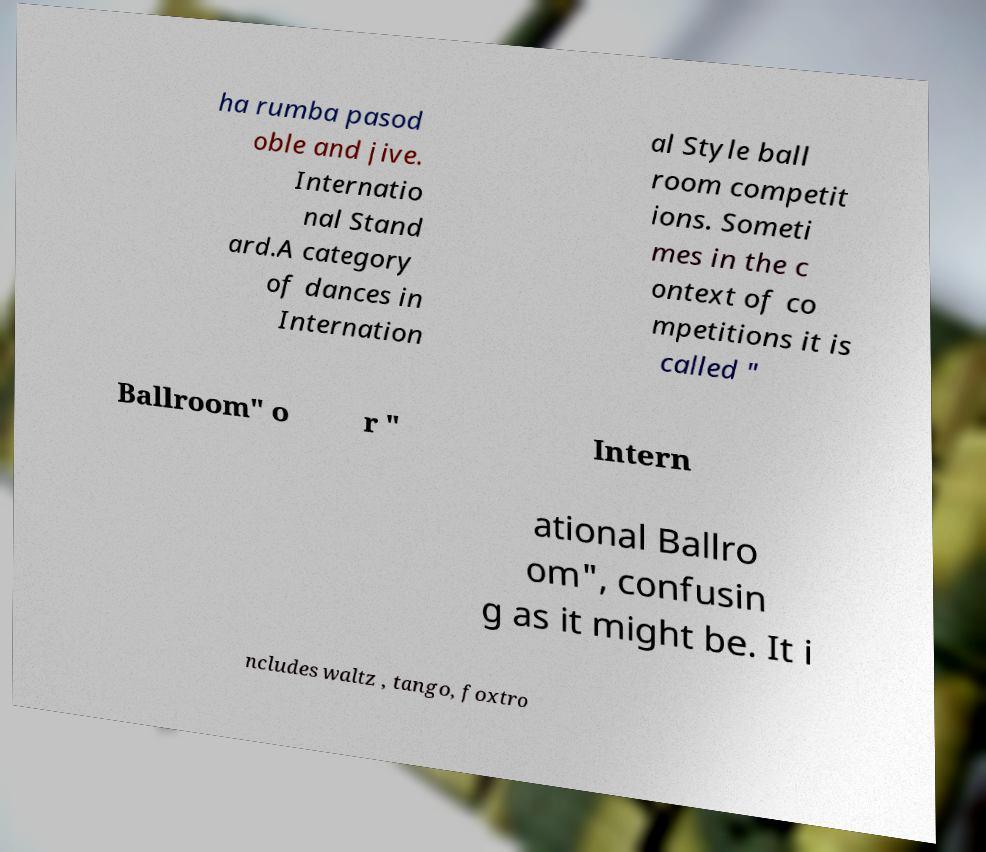Could you tell me more about International Style ballroom competitions? Certainly! International Style ballroom competitions are divided into two categories: 'Standard' and 'Latin.' They are judged on various criteria such as technique, timing, and presentation. Dancers from all over the world train rigorously to compete at various levels, from amateur to professional, often culminating in prestigious championships. 